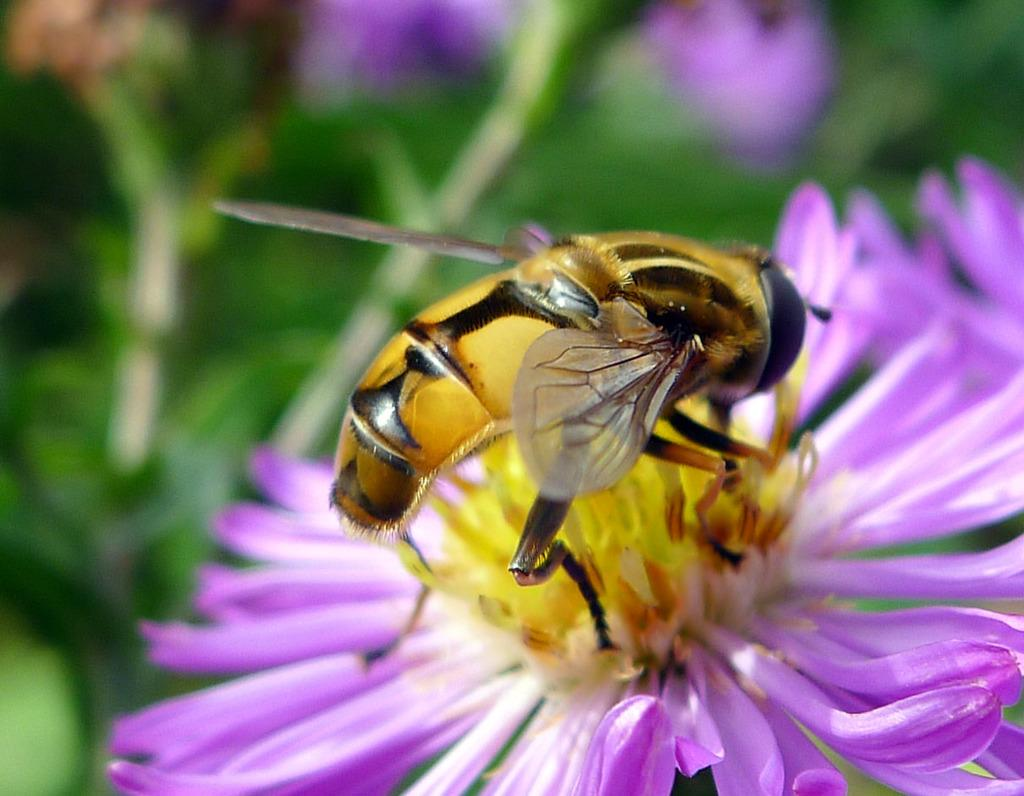What is the main subject of the picture? The main subject of the picture is an insect. Where is the insect located in the image? The insect is on a flower. Can you describe the background of the image? The background of the image is blurred. What type of jam is being spread on the bread in the image? There is no bread or jam present in the image; it features an insect on a flower with a blurred background. 